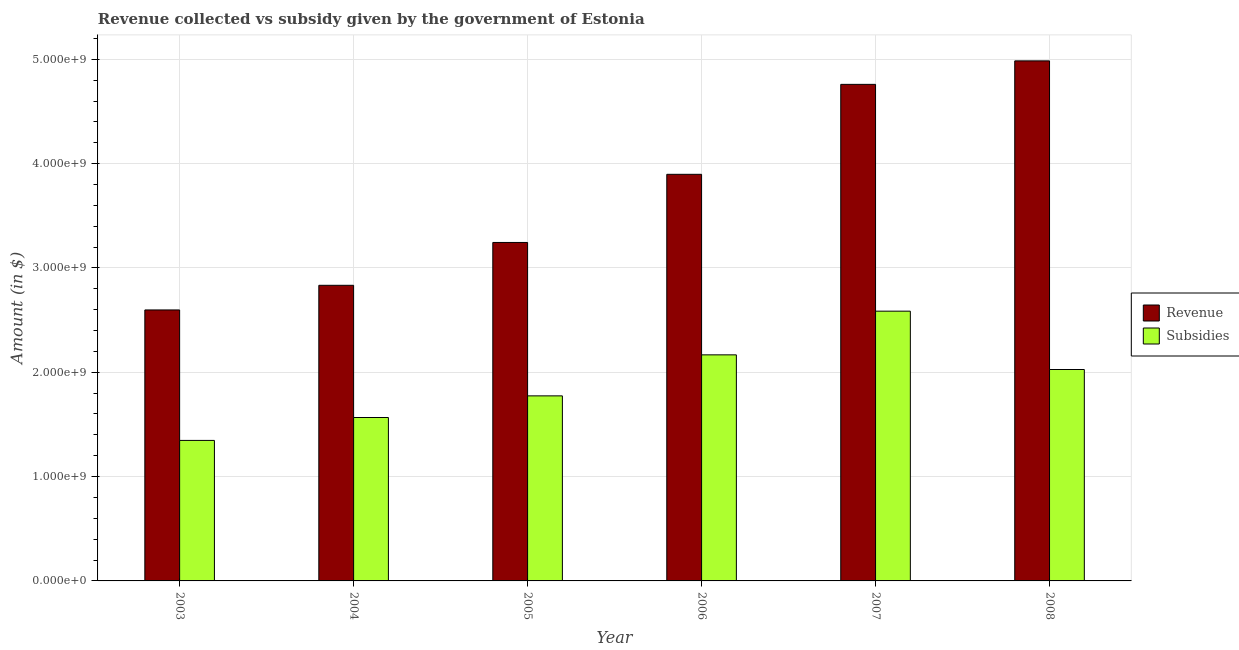How many different coloured bars are there?
Make the answer very short. 2. How many bars are there on the 3rd tick from the right?
Give a very brief answer. 2. What is the amount of revenue collected in 2007?
Provide a succinct answer. 4.76e+09. Across all years, what is the maximum amount of revenue collected?
Your answer should be compact. 4.98e+09. Across all years, what is the minimum amount of subsidies given?
Your answer should be compact. 1.35e+09. What is the total amount of revenue collected in the graph?
Provide a succinct answer. 2.23e+1. What is the difference between the amount of revenue collected in 2003 and that in 2005?
Offer a very short reply. -6.47e+08. What is the difference between the amount of revenue collected in 2008 and the amount of subsidies given in 2006?
Keep it short and to the point. 1.09e+09. What is the average amount of subsidies given per year?
Your response must be concise. 1.91e+09. In how many years, is the amount of revenue collected greater than 200000000 $?
Give a very brief answer. 6. What is the ratio of the amount of subsidies given in 2007 to that in 2008?
Provide a succinct answer. 1.28. What is the difference between the highest and the second highest amount of subsidies given?
Make the answer very short. 4.19e+08. What is the difference between the highest and the lowest amount of revenue collected?
Keep it short and to the point. 2.39e+09. Is the sum of the amount of revenue collected in 2005 and 2008 greater than the maximum amount of subsidies given across all years?
Make the answer very short. Yes. What does the 2nd bar from the left in 2006 represents?
Provide a succinct answer. Subsidies. What does the 2nd bar from the right in 2007 represents?
Provide a succinct answer. Revenue. How many bars are there?
Your answer should be very brief. 12. Are the values on the major ticks of Y-axis written in scientific E-notation?
Offer a terse response. Yes. How are the legend labels stacked?
Offer a terse response. Vertical. What is the title of the graph?
Keep it short and to the point. Revenue collected vs subsidy given by the government of Estonia. What is the label or title of the Y-axis?
Make the answer very short. Amount (in $). What is the Amount (in $) in Revenue in 2003?
Offer a very short reply. 2.60e+09. What is the Amount (in $) of Subsidies in 2003?
Your answer should be very brief. 1.35e+09. What is the Amount (in $) of Revenue in 2004?
Keep it short and to the point. 2.83e+09. What is the Amount (in $) in Subsidies in 2004?
Provide a succinct answer. 1.57e+09. What is the Amount (in $) of Revenue in 2005?
Offer a very short reply. 3.24e+09. What is the Amount (in $) of Subsidies in 2005?
Make the answer very short. 1.77e+09. What is the Amount (in $) of Revenue in 2006?
Make the answer very short. 3.90e+09. What is the Amount (in $) in Subsidies in 2006?
Give a very brief answer. 2.17e+09. What is the Amount (in $) of Revenue in 2007?
Provide a short and direct response. 4.76e+09. What is the Amount (in $) of Subsidies in 2007?
Keep it short and to the point. 2.59e+09. What is the Amount (in $) in Revenue in 2008?
Offer a very short reply. 4.98e+09. What is the Amount (in $) in Subsidies in 2008?
Offer a terse response. 2.03e+09. Across all years, what is the maximum Amount (in $) in Revenue?
Offer a very short reply. 4.98e+09. Across all years, what is the maximum Amount (in $) in Subsidies?
Provide a short and direct response. 2.59e+09. Across all years, what is the minimum Amount (in $) in Revenue?
Keep it short and to the point. 2.60e+09. Across all years, what is the minimum Amount (in $) in Subsidies?
Make the answer very short. 1.35e+09. What is the total Amount (in $) of Revenue in the graph?
Make the answer very short. 2.23e+1. What is the total Amount (in $) in Subsidies in the graph?
Provide a short and direct response. 1.15e+1. What is the difference between the Amount (in $) of Revenue in 2003 and that in 2004?
Your response must be concise. -2.36e+08. What is the difference between the Amount (in $) of Subsidies in 2003 and that in 2004?
Ensure brevity in your answer.  -2.20e+08. What is the difference between the Amount (in $) in Revenue in 2003 and that in 2005?
Ensure brevity in your answer.  -6.47e+08. What is the difference between the Amount (in $) of Subsidies in 2003 and that in 2005?
Ensure brevity in your answer.  -4.27e+08. What is the difference between the Amount (in $) of Revenue in 2003 and that in 2006?
Your response must be concise. -1.30e+09. What is the difference between the Amount (in $) in Subsidies in 2003 and that in 2006?
Your response must be concise. -8.20e+08. What is the difference between the Amount (in $) in Revenue in 2003 and that in 2007?
Provide a succinct answer. -2.16e+09. What is the difference between the Amount (in $) of Subsidies in 2003 and that in 2007?
Make the answer very short. -1.24e+09. What is the difference between the Amount (in $) of Revenue in 2003 and that in 2008?
Offer a very short reply. -2.39e+09. What is the difference between the Amount (in $) in Subsidies in 2003 and that in 2008?
Give a very brief answer. -6.80e+08. What is the difference between the Amount (in $) in Revenue in 2004 and that in 2005?
Make the answer very short. -4.11e+08. What is the difference between the Amount (in $) in Subsidies in 2004 and that in 2005?
Your answer should be compact. -2.08e+08. What is the difference between the Amount (in $) of Revenue in 2004 and that in 2006?
Offer a terse response. -1.06e+09. What is the difference between the Amount (in $) of Subsidies in 2004 and that in 2006?
Your response must be concise. -6.01e+08. What is the difference between the Amount (in $) of Revenue in 2004 and that in 2007?
Your answer should be very brief. -1.93e+09. What is the difference between the Amount (in $) in Subsidies in 2004 and that in 2007?
Keep it short and to the point. -1.02e+09. What is the difference between the Amount (in $) in Revenue in 2004 and that in 2008?
Keep it short and to the point. -2.15e+09. What is the difference between the Amount (in $) in Subsidies in 2004 and that in 2008?
Give a very brief answer. -4.60e+08. What is the difference between the Amount (in $) in Revenue in 2005 and that in 2006?
Provide a short and direct response. -6.53e+08. What is the difference between the Amount (in $) of Subsidies in 2005 and that in 2006?
Offer a terse response. -3.93e+08. What is the difference between the Amount (in $) of Revenue in 2005 and that in 2007?
Give a very brief answer. -1.52e+09. What is the difference between the Amount (in $) of Subsidies in 2005 and that in 2007?
Give a very brief answer. -8.12e+08. What is the difference between the Amount (in $) of Revenue in 2005 and that in 2008?
Offer a terse response. -1.74e+09. What is the difference between the Amount (in $) in Subsidies in 2005 and that in 2008?
Provide a succinct answer. -2.53e+08. What is the difference between the Amount (in $) in Revenue in 2006 and that in 2007?
Make the answer very short. -8.62e+08. What is the difference between the Amount (in $) of Subsidies in 2006 and that in 2007?
Your response must be concise. -4.19e+08. What is the difference between the Amount (in $) of Revenue in 2006 and that in 2008?
Keep it short and to the point. -1.09e+09. What is the difference between the Amount (in $) of Subsidies in 2006 and that in 2008?
Your response must be concise. 1.40e+08. What is the difference between the Amount (in $) in Revenue in 2007 and that in 2008?
Offer a very short reply. -2.25e+08. What is the difference between the Amount (in $) of Subsidies in 2007 and that in 2008?
Ensure brevity in your answer.  5.59e+08. What is the difference between the Amount (in $) of Revenue in 2003 and the Amount (in $) of Subsidies in 2004?
Give a very brief answer. 1.03e+09. What is the difference between the Amount (in $) of Revenue in 2003 and the Amount (in $) of Subsidies in 2005?
Your answer should be very brief. 8.24e+08. What is the difference between the Amount (in $) of Revenue in 2003 and the Amount (in $) of Subsidies in 2006?
Provide a short and direct response. 4.30e+08. What is the difference between the Amount (in $) of Revenue in 2003 and the Amount (in $) of Subsidies in 2007?
Provide a short and direct response. 1.17e+07. What is the difference between the Amount (in $) in Revenue in 2003 and the Amount (in $) in Subsidies in 2008?
Offer a very short reply. 5.71e+08. What is the difference between the Amount (in $) in Revenue in 2004 and the Amount (in $) in Subsidies in 2005?
Your answer should be compact. 1.06e+09. What is the difference between the Amount (in $) of Revenue in 2004 and the Amount (in $) of Subsidies in 2006?
Provide a succinct answer. 6.67e+08. What is the difference between the Amount (in $) in Revenue in 2004 and the Amount (in $) in Subsidies in 2007?
Make the answer very short. 2.48e+08. What is the difference between the Amount (in $) in Revenue in 2004 and the Amount (in $) in Subsidies in 2008?
Give a very brief answer. 8.07e+08. What is the difference between the Amount (in $) of Revenue in 2005 and the Amount (in $) of Subsidies in 2006?
Your answer should be compact. 1.08e+09. What is the difference between the Amount (in $) of Revenue in 2005 and the Amount (in $) of Subsidies in 2007?
Make the answer very short. 6.59e+08. What is the difference between the Amount (in $) of Revenue in 2005 and the Amount (in $) of Subsidies in 2008?
Give a very brief answer. 1.22e+09. What is the difference between the Amount (in $) in Revenue in 2006 and the Amount (in $) in Subsidies in 2007?
Your answer should be very brief. 1.31e+09. What is the difference between the Amount (in $) of Revenue in 2006 and the Amount (in $) of Subsidies in 2008?
Keep it short and to the point. 1.87e+09. What is the difference between the Amount (in $) of Revenue in 2007 and the Amount (in $) of Subsidies in 2008?
Offer a very short reply. 2.73e+09. What is the average Amount (in $) in Revenue per year?
Offer a terse response. 3.72e+09. What is the average Amount (in $) in Subsidies per year?
Provide a short and direct response. 1.91e+09. In the year 2003, what is the difference between the Amount (in $) in Revenue and Amount (in $) in Subsidies?
Ensure brevity in your answer.  1.25e+09. In the year 2004, what is the difference between the Amount (in $) in Revenue and Amount (in $) in Subsidies?
Ensure brevity in your answer.  1.27e+09. In the year 2005, what is the difference between the Amount (in $) of Revenue and Amount (in $) of Subsidies?
Provide a short and direct response. 1.47e+09. In the year 2006, what is the difference between the Amount (in $) of Revenue and Amount (in $) of Subsidies?
Offer a very short reply. 1.73e+09. In the year 2007, what is the difference between the Amount (in $) of Revenue and Amount (in $) of Subsidies?
Your response must be concise. 2.17e+09. In the year 2008, what is the difference between the Amount (in $) of Revenue and Amount (in $) of Subsidies?
Ensure brevity in your answer.  2.96e+09. What is the ratio of the Amount (in $) in Revenue in 2003 to that in 2004?
Provide a short and direct response. 0.92. What is the ratio of the Amount (in $) of Subsidies in 2003 to that in 2004?
Your answer should be compact. 0.86. What is the ratio of the Amount (in $) of Revenue in 2003 to that in 2005?
Give a very brief answer. 0.8. What is the ratio of the Amount (in $) of Subsidies in 2003 to that in 2005?
Your answer should be very brief. 0.76. What is the ratio of the Amount (in $) in Revenue in 2003 to that in 2006?
Provide a succinct answer. 0.67. What is the ratio of the Amount (in $) of Subsidies in 2003 to that in 2006?
Keep it short and to the point. 0.62. What is the ratio of the Amount (in $) of Revenue in 2003 to that in 2007?
Give a very brief answer. 0.55. What is the ratio of the Amount (in $) in Subsidies in 2003 to that in 2007?
Offer a very short reply. 0.52. What is the ratio of the Amount (in $) in Revenue in 2003 to that in 2008?
Make the answer very short. 0.52. What is the ratio of the Amount (in $) of Subsidies in 2003 to that in 2008?
Keep it short and to the point. 0.66. What is the ratio of the Amount (in $) of Revenue in 2004 to that in 2005?
Your answer should be compact. 0.87. What is the ratio of the Amount (in $) of Subsidies in 2004 to that in 2005?
Your answer should be compact. 0.88. What is the ratio of the Amount (in $) of Revenue in 2004 to that in 2006?
Provide a succinct answer. 0.73. What is the ratio of the Amount (in $) of Subsidies in 2004 to that in 2006?
Offer a terse response. 0.72. What is the ratio of the Amount (in $) of Revenue in 2004 to that in 2007?
Your answer should be compact. 0.6. What is the ratio of the Amount (in $) in Subsidies in 2004 to that in 2007?
Your answer should be very brief. 0.61. What is the ratio of the Amount (in $) in Revenue in 2004 to that in 2008?
Offer a very short reply. 0.57. What is the ratio of the Amount (in $) of Subsidies in 2004 to that in 2008?
Offer a very short reply. 0.77. What is the ratio of the Amount (in $) of Revenue in 2005 to that in 2006?
Make the answer very short. 0.83. What is the ratio of the Amount (in $) of Subsidies in 2005 to that in 2006?
Give a very brief answer. 0.82. What is the ratio of the Amount (in $) in Revenue in 2005 to that in 2007?
Offer a very short reply. 0.68. What is the ratio of the Amount (in $) in Subsidies in 2005 to that in 2007?
Give a very brief answer. 0.69. What is the ratio of the Amount (in $) of Revenue in 2005 to that in 2008?
Give a very brief answer. 0.65. What is the ratio of the Amount (in $) in Subsidies in 2005 to that in 2008?
Offer a very short reply. 0.88. What is the ratio of the Amount (in $) of Revenue in 2006 to that in 2007?
Provide a succinct answer. 0.82. What is the ratio of the Amount (in $) in Subsidies in 2006 to that in 2007?
Your answer should be very brief. 0.84. What is the ratio of the Amount (in $) in Revenue in 2006 to that in 2008?
Make the answer very short. 0.78. What is the ratio of the Amount (in $) of Subsidies in 2006 to that in 2008?
Provide a short and direct response. 1.07. What is the ratio of the Amount (in $) in Revenue in 2007 to that in 2008?
Ensure brevity in your answer.  0.95. What is the ratio of the Amount (in $) of Subsidies in 2007 to that in 2008?
Your answer should be compact. 1.28. What is the difference between the highest and the second highest Amount (in $) of Revenue?
Offer a terse response. 2.25e+08. What is the difference between the highest and the second highest Amount (in $) in Subsidies?
Your response must be concise. 4.19e+08. What is the difference between the highest and the lowest Amount (in $) of Revenue?
Provide a succinct answer. 2.39e+09. What is the difference between the highest and the lowest Amount (in $) in Subsidies?
Give a very brief answer. 1.24e+09. 